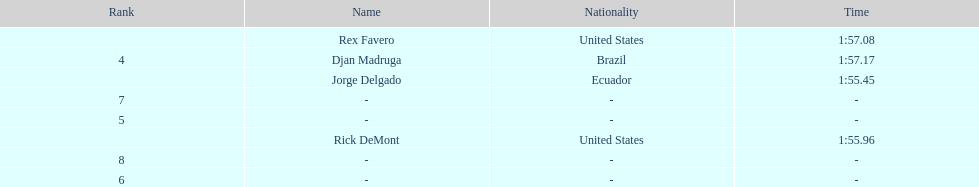Favero completed in 1:5 1:57.17. 